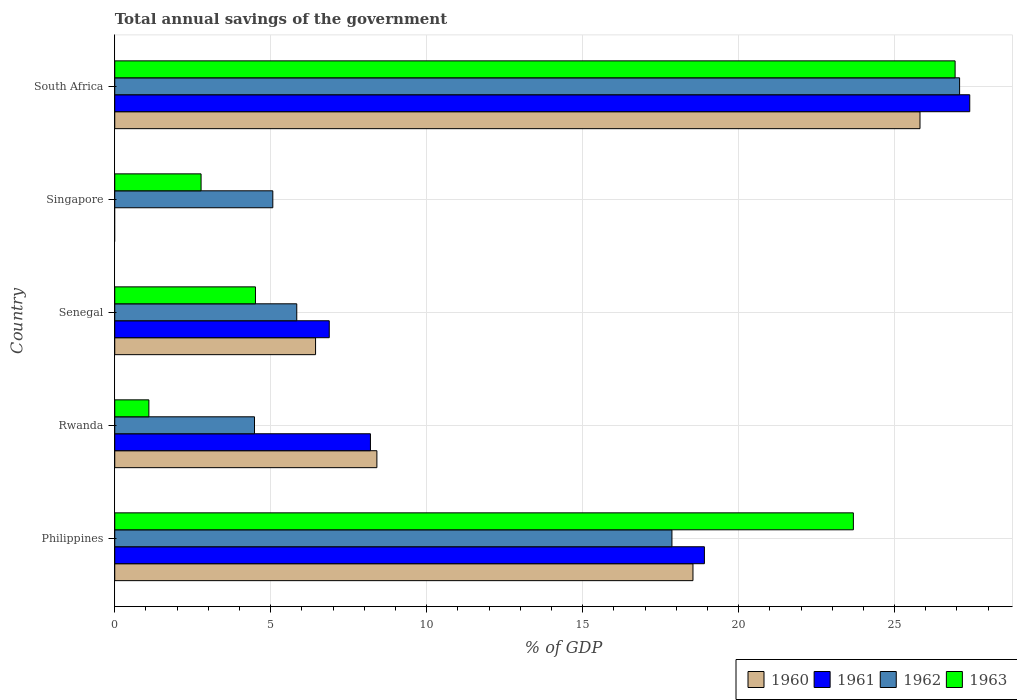Are the number of bars per tick equal to the number of legend labels?
Offer a terse response. No. How many bars are there on the 3rd tick from the top?
Offer a terse response. 4. What is the label of the 2nd group of bars from the top?
Provide a short and direct response. Singapore. What is the total annual savings of the government in 1960 in Senegal?
Ensure brevity in your answer.  6.44. Across all countries, what is the maximum total annual savings of the government in 1960?
Make the answer very short. 25.81. Across all countries, what is the minimum total annual savings of the government in 1960?
Your response must be concise. 0. In which country was the total annual savings of the government in 1962 maximum?
Ensure brevity in your answer.  South Africa. What is the total total annual savings of the government in 1961 in the graph?
Provide a succinct answer. 61.38. What is the difference between the total annual savings of the government in 1962 in Philippines and that in Rwanda?
Make the answer very short. 13.38. What is the difference between the total annual savings of the government in 1962 in Rwanda and the total annual savings of the government in 1961 in Senegal?
Your response must be concise. -2.4. What is the average total annual savings of the government in 1963 per country?
Your answer should be very brief. 11.8. What is the difference between the total annual savings of the government in 1961 and total annual savings of the government in 1962 in Rwanda?
Give a very brief answer. 3.72. What is the ratio of the total annual savings of the government in 1963 in Philippines to that in South Africa?
Offer a very short reply. 0.88. Is the total annual savings of the government in 1962 in Singapore less than that in South Africa?
Your answer should be very brief. Yes. Is the difference between the total annual savings of the government in 1961 in Philippines and Senegal greater than the difference between the total annual savings of the government in 1962 in Philippines and Senegal?
Your answer should be very brief. No. What is the difference between the highest and the second highest total annual savings of the government in 1960?
Your answer should be very brief. 7.28. What is the difference between the highest and the lowest total annual savings of the government in 1960?
Provide a short and direct response. 25.81. In how many countries, is the total annual savings of the government in 1963 greater than the average total annual savings of the government in 1963 taken over all countries?
Give a very brief answer. 2. Is it the case that in every country, the sum of the total annual savings of the government in 1961 and total annual savings of the government in 1963 is greater than the sum of total annual savings of the government in 1960 and total annual savings of the government in 1962?
Give a very brief answer. No. How many countries are there in the graph?
Offer a terse response. 5. Does the graph contain any zero values?
Offer a very short reply. Yes. Where does the legend appear in the graph?
Your answer should be very brief. Bottom right. How many legend labels are there?
Offer a very short reply. 4. How are the legend labels stacked?
Give a very brief answer. Horizontal. What is the title of the graph?
Give a very brief answer. Total annual savings of the government. Does "1986" appear as one of the legend labels in the graph?
Provide a succinct answer. No. What is the label or title of the X-axis?
Your answer should be very brief. % of GDP. What is the % of GDP of 1960 in Philippines?
Give a very brief answer. 18.54. What is the % of GDP of 1961 in Philippines?
Your response must be concise. 18.9. What is the % of GDP of 1962 in Philippines?
Your answer should be very brief. 17.86. What is the % of GDP of 1963 in Philippines?
Keep it short and to the point. 23.68. What is the % of GDP of 1960 in Rwanda?
Give a very brief answer. 8.4. What is the % of GDP in 1961 in Rwanda?
Ensure brevity in your answer.  8.2. What is the % of GDP of 1962 in Rwanda?
Provide a succinct answer. 4.48. What is the % of GDP of 1963 in Rwanda?
Make the answer very short. 1.09. What is the % of GDP in 1960 in Senegal?
Your response must be concise. 6.44. What is the % of GDP of 1961 in Senegal?
Offer a very short reply. 6.88. What is the % of GDP of 1962 in Senegal?
Your answer should be compact. 5.83. What is the % of GDP in 1963 in Senegal?
Your answer should be compact. 4.51. What is the % of GDP of 1961 in Singapore?
Provide a short and direct response. 0. What is the % of GDP in 1962 in Singapore?
Offer a very short reply. 5.07. What is the % of GDP in 1963 in Singapore?
Ensure brevity in your answer.  2.77. What is the % of GDP in 1960 in South Africa?
Make the answer very short. 25.81. What is the % of GDP of 1961 in South Africa?
Offer a very short reply. 27.41. What is the % of GDP in 1962 in South Africa?
Ensure brevity in your answer.  27.08. What is the % of GDP in 1963 in South Africa?
Give a very brief answer. 26.94. Across all countries, what is the maximum % of GDP in 1960?
Offer a very short reply. 25.81. Across all countries, what is the maximum % of GDP in 1961?
Give a very brief answer. 27.41. Across all countries, what is the maximum % of GDP of 1962?
Ensure brevity in your answer.  27.08. Across all countries, what is the maximum % of GDP in 1963?
Offer a terse response. 26.94. Across all countries, what is the minimum % of GDP of 1961?
Offer a terse response. 0. Across all countries, what is the minimum % of GDP in 1962?
Give a very brief answer. 4.48. Across all countries, what is the minimum % of GDP of 1963?
Give a very brief answer. 1.09. What is the total % of GDP in 1960 in the graph?
Your response must be concise. 59.19. What is the total % of GDP of 1961 in the graph?
Provide a succinct answer. 61.38. What is the total % of GDP in 1962 in the graph?
Give a very brief answer. 60.33. What is the total % of GDP in 1963 in the graph?
Provide a short and direct response. 58.99. What is the difference between the % of GDP in 1960 in Philippines and that in Rwanda?
Your response must be concise. 10.13. What is the difference between the % of GDP of 1961 in Philippines and that in Rwanda?
Keep it short and to the point. 10.71. What is the difference between the % of GDP in 1962 in Philippines and that in Rwanda?
Ensure brevity in your answer.  13.38. What is the difference between the % of GDP of 1963 in Philippines and that in Rwanda?
Your response must be concise. 22.58. What is the difference between the % of GDP of 1960 in Philippines and that in Senegal?
Ensure brevity in your answer.  12.1. What is the difference between the % of GDP in 1961 in Philippines and that in Senegal?
Offer a very short reply. 12.03. What is the difference between the % of GDP in 1962 in Philippines and that in Senegal?
Offer a very short reply. 12.03. What is the difference between the % of GDP in 1963 in Philippines and that in Senegal?
Give a very brief answer. 19.17. What is the difference between the % of GDP in 1962 in Philippines and that in Singapore?
Provide a short and direct response. 12.79. What is the difference between the % of GDP in 1963 in Philippines and that in Singapore?
Keep it short and to the point. 20.91. What is the difference between the % of GDP of 1960 in Philippines and that in South Africa?
Ensure brevity in your answer.  -7.28. What is the difference between the % of GDP in 1961 in Philippines and that in South Africa?
Your answer should be compact. -8.51. What is the difference between the % of GDP in 1962 in Philippines and that in South Africa?
Give a very brief answer. -9.22. What is the difference between the % of GDP in 1963 in Philippines and that in South Africa?
Provide a short and direct response. -3.26. What is the difference between the % of GDP of 1960 in Rwanda and that in Senegal?
Provide a short and direct response. 1.97. What is the difference between the % of GDP of 1961 in Rwanda and that in Senegal?
Give a very brief answer. 1.32. What is the difference between the % of GDP of 1962 in Rwanda and that in Senegal?
Offer a very short reply. -1.35. What is the difference between the % of GDP of 1963 in Rwanda and that in Senegal?
Offer a terse response. -3.42. What is the difference between the % of GDP in 1962 in Rwanda and that in Singapore?
Provide a short and direct response. -0.59. What is the difference between the % of GDP of 1963 in Rwanda and that in Singapore?
Ensure brevity in your answer.  -1.67. What is the difference between the % of GDP of 1960 in Rwanda and that in South Africa?
Your answer should be compact. -17.41. What is the difference between the % of GDP of 1961 in Rwanda and that in South Africa?
Your answer should be compact. -19.21. What is the difference between the % of GDP of 1962 in Rwanda and that in South Africa?
Ensure brevity in your answer.  -22.6. What is the difference between the % of GDP in 1963 in Rwanda and that in South Africa?
Keep it short and to the point. -25.85. What is the difference between the % of GDP of 1962 in Senegal and that in Singapore?
Make the answer very short. 0.77. What is the difference between the % of GDP in 1963 in Senegal and that in Singapore?
Your answer should be compact. 1.74. What is the difference between the % of GDP of 1960 in Senegal and that in South Africa?
Make the answer very short. -19.38. What is the difference between the % of GDP of 1961 in Senegal and that in South Africa?
Give a very brief answer. -20.53. What is the difference between the % of GDP in 1962 in Senegal and that in South Africa?
Your answer should be compact. -21.25. What is the difference between the % of GDP of 1963 in Senegal and that in South Africa?
Offer a very short reply. -22.43. What is the difference between the % of GDP in 1962 in Singapore and that in South Africa?
Your response must be concise. -22.02. What is the difference between the % of GDP of 1963 in Singapore and that in South Africa?
Give a very brief answer. -24.17. What is the difference between the % of GDP in 1960 in Philippines and the % of GDP in 1961 in Rwanda?
Ensure brevity in your answer.  10.34. What is the difference between the % of GDP of 1960 in Philippines and the % of GDP of 1962 in Rwanda?
Your answer should be very brief. 14.06. What is the difference between the % of GDP of 1960 in Philippines and the % of GDP of 1963 in Rwanda?
Keep it short and to the point. 17.44. What is the difference between the % of GDP of 1961 in Philippines and the % of GDP of 1962 in Rwanda?
Offer a terse response. 14.42. What is the difference between the % of GDP in 1961 in Philippines and the % of GDP in 1963 in Rwanda?
Offer a terse response. 17.81. What is the difference between the % of GDP in 1962 in Philippines and the % of GDP in 1963 in Rwanda?
Give a very brief answer. 16.77. What is the difference between the % of GDP of 1960 in Philippines and the % of GDP of 1961 in Senegal?
Your response must be concise. 11.66. What is the difference between the % of GDP in 1960 in Philippines and the % of GDP in 1962 in Senegal?
Make the answer very short. 12.7. What is the difference between the % of GDP of 1960 in Philippines and the % of GDP of 1963 in Senegal?
Give a very brief answer. 14.03. What is the difference between the % of GDP in 1961 in Philippines and the % of GDP in 1962 in Senegal?
Ensure brevity in your answer.  13.07. What is the difference between the % of GDP of 1961 in Philippines and the % of GDP of 1963 in Senegal?
Provide a short and direct response. 14.39. What is the difference between the % of GDP in 1962 in Philippines and the % of GDP in 1963 in Senegal?
Give a very brief answer. 13.35. What is the difference between the % of GDP in 1960 in Philippines and the % of GDP in 1962 in Singapore?
Make the answer very short. 13.47. What is the difference between the % of GDP of 1960 in Philippines and the % of GDP of 1963 in Singapore?
Your response must be concise. 15.77. What is the difference between the % of GDP in 1961 in Philippines and the % of GDP in 1962 in Singapore?
Your response must be concise. 13.84. What is the difference between the % of GDP of 1961 in Philippines and the % of GDP of 1963 in Singapore?
Your answer should be compact. 16.14. What is the difference between the % of GDP in 1962 in Philippines and the % of GDP in 1963 in Singapore?
Provide a succinct answer. 15.09. What is the difference between the % of GDP of 1960 in Philippines and the % of GDP of 1961 in South Africa?
Provide a succinct answer. -8.87. What is the difference between the % of GDP of 1960 in Philippines and the % of GDP of 1962 in South Africa?
Ensure brevity in your answer.  -8.55. What is the difference between the % of GDP of 1960 in Philippines and the % of GDP of 1963 in South Africa?
Ensure brevity in your answer.  -8.4. What is the difference between the % of GDP in 1961 in Philippines and the % of GDP in 1962 in South Africa?
Offer a terse response. -8.18. What is the difference between the % of GDP in 1961 in Philippines and the % of GDP in 1963 in South Africa?
Your answer should be compact. -8.04. What is the difference between the % of GDP of 1962 in Philippines and the % of GDP of 1963 in South Africa?
Offer a terse response. -9.08. What is the difference between the % of GDP in 1960 in Rwanda and the % of GDP in 1961 in Senegal?
Give a very brief answer. 1.53. What is the difference between the % of GDP of 1960 in Rwanda and the % of GDP of 1962 in Senegal?
Offer a very short reply. 2.57. What is the difference between the % of GDP in 1960 in Rwanda and the % of GDP in 1963 in Senegal?
Offer a very short reply. 3.89. What is the difference between the % of GDP in 1961 in Rwanda and the % of GDP in 1962 in Senegal?
Offer a very short reply. 2.36. What is the difference between the % of GDP of 1961 in Rwanda and the % of GDP of 1963 in Senegal?
Provide a succinct answer. 3.69. What is the difference between the % of GDP in 1962 in Rwanda and the % of GDP in 1963 in Senegal?
Ensure brevity in your answer.  -0.03. What is the difference between the % of GDP in 1960 in Rwanda and the % of GDP in 1962 in Singapore?
Your response must be concise. 3.34. What is the difference between the % of GDP of 1960 in Rwanda and the % of GDP of 1963 in Singapore?
Offer a terse response. 5.64. What is the difference between the % of GDP in 1961 in Rwanda and the % of GDP in 1962 in Singapore?
Your answer should be compact. 3.13. What is the difference between the % of GDP of 1961 in Rwanda and the % of GDP of 1963 in Singapore?
Provide a short and direct response. 5.43. What is the difference between the % of GDP of 1962 in Rwanda and the % of GDP of 1963 in Singapore?
Provide a succinct answer. 1.71. What is the difference between the % of GDP of 1960 in Rwanda and the % of GDP of 1961 in South Africa?
Your answer should be very brief. -19.01. What is the difference between the % of GDP of 1960 in Rwanda and the % of GDP of 1962 in South Africa?
Your response must be concise. -18.68. What is the difference between the % of GDP of 1960 in Rwanda and the % of GDP of 1963 in South Africa?
Your response must be concise. -18.54. What is the difference between the % of GDP of 1961 in Rwanda and the % of GDP of 1962 in South Africa?
Give a very brief answer. -18.89. What is the difference between the % of GDP of 1961 in Rwanda and the % of GDP of 1963 in South Africa?
Offer a terse response. -18.74. What is the difference between the % of GDP in 1962 in Rwanda and the % of GDP in 1963 in South Africa?
Provide a succinct answer. -22.46. What is the difference between the % of GDP of 1960 in Senegal and the % of GDP of 1962 in Singapore?
Your answer should be compact. 1.37. What is the difference between the % of GDP in 1960 in Senegal and the % of GDP in 1963 in Singapore?
Give a very brief answer. 3.67. What is the difference between the % of GDP in 1961 in Senegal and the % of GDP in 1962 in Singapore?
Provide a short and direct response. 1.81. What is the difference between the % of GDP in 1961 in Senegal and the % of GDP in 1963 in Singapore?
Offer a very short reply. 4.11. What is the difference between the % of GDP in 1962 in Senegal and the % of GDP in 1963 in Singapore?
Ensure brevity in your answer.  3.07. What is the difference between the % of GDP in 1960 in Senegal and the % of GDP in 1961 in South Africa?
Your answer should be very brief. -20.97. What is the difference between the % of GDP in 1960 in Senegal and the % of GDP in 1962 in South Africa?
Provide a succinct answer. -20.65. What is the difference between the % of GDP in 1960 in Senegal and the % of GDP in 1963 in South Africa?
Ensure brevity in your answer.  -20.5. What is the difference between the % of GDP in 1961 in Senegal and the % of GDP in 1962 in South Africa?
Keep it short and to the point. -20.21. What is the difference between the % of GDP in 1961 in Senegal and the % of GDP in 1963 in South Africa?
Your answer should be very brief. -20.06. What is the difference between the % of GDP of 1962 in Senegal and the % of GDP of 1963 in South Africa?
Offer a terse response. -21.11. What is the difference between the % of GDP of 1962 in Singapore and the % of GDP of 1963 in South Africa?
Offer a terse response. -21.87. What is the average % of GDP in 1960 per country?
Provide a short and direct response. 11.84. What is the average % of GDP in 1961 per country?
Provide a succinct answer. 12.28. What is the average % of GDP of 1962 per country?
Keep it short and to the point. 12.07. What is the average % of GDP of 1963 per country?
Keep it short and to the point. 11.8. What is the difference between the % of GDP in 1960 and % of GDP in 1961 in Philippines?
Provide a succinct answer. -0.37. What is the difference between the % of GDP of 1960 and % of GDP of 1962 in Philippines?
Your answer should be compact. 0.67. What is the difference between the % of GDP of 1960 and % of GDP of 1963 in Philippines?
Offer a terse response. -5.14. What is the difference between the % of GDP of 1961 and % of GDP of 1962 in Philippines?
Ensure brevity in your answer.  1.04. What is the difference between the % of GDP of 1961 and % of GDP of 1963 in Philippines?
Keep it short and to the point. -4.78. What is the difference between the % of GDP of 1962 and % of GDP of 1963 in Philippines?
Your answer should be very brief. -5.82. What is the difference between the % of GDP in 1960 and % of GDP in 1961 in Rwanda?
Ensure brevity in your answer.  0.21. What is the difference between the % of GDP in 1960 and % of GDP in 1962 in Rwanda?
Provide a succinct answer. 3.92. What is the difference between the % of GDP of 1960 and % of GDP of 1963 in Rwanda?
Make the answer very short. 7.31. What is the difference between the % of GDP of 1961 and % of GDP of 1962 in Rwanda?
Offer a terse response. 3.72. What is the difference between the % of GDP of 1961 and % of GDP of 1963 in Rwanda?
Your response must be concise. 7.1. What is the difference between the % of GDP of 1962 and % of GDP of 1963 in Rwanda?
Offer a terse response. 3.39. What is the difference between the % of GDP in 1960 and % of GDP in 1961 in Senegal?
Provide a succinct answer. -0.44. What is the difference between the % of GDP of 1960 and % of GDP of 1962 in Senegal?
Your answer should be compact. 0.6. What is the difference between the % of GDP of 1960 and % of GDP of 1963 in Senegal?
Offer a very short reply. 1.93. What is the difference between the % of GDP in 1961 and % of GDP in 1962 in Senegal?
Provide a short and direct response. 1.04. What is the difference between the % of GDP in 1961 and % of GDP in 1963 in Senegal?
Offer a very short reply. 2.37. What is the difference between the % of GDP in 1962 and % of GDP in 1963 in Senegal?
Make the answer very short. 1.32. What is the difference between the % of GDP in 1962 and % of GDP in 1963 in Singapore?
Keep it short and to the point. 2.3. What is the difference between the % of GDP of 1960 and % of GDP of 1961 in South Africa?
Make the answer very short. -1.59. What is the difference between the % of GDP of 1960 and % of GDP of 1962 in South Africa?
Offer a terse response. -1.27. What is the difference between the % of GDP in 1960 and % of GDP in 1963 in South Africa?
Keep it short and to the point. -1.13. What is the difference between the % of GDP in 1961 and % of GDP in 1962 in South Africa?
Make the answer very short. 0.33. What is the difference between the % of GDP of 1961 and % of GDP of 1963 in South Africa?
Give a very brief answer. 0.47. What is the difference between the % of GDP of 1962 and % of GDP of 1963 in South Africa?
Keep it short and to the point. 0.14. What is the ratio of the % of GDP of 1960 in Philippines to that in Rwanda?
Offer a very short reply. 2.21. What is the ratio of the % of GDP of 1961 in Philippines to that in Rwanda?
Your response must be concise. 2.31. What is the ratio of the % of GDP of 1962 in Philippines to that in Rwanda?
Your response must be concise. 3.99. What is the ratio of the % of GDP in 1963 in Philippines to that in Rwanda?
Provide a short and direct response. 21.65. What is the ratio of the % of GDP of 1960 in Philippines to that in Senegal?
Keep it short and to the point. 2.88. What is the ratio of the % of GDP in 1961 in Philippines to that in Senegal?
Ensure brevity in your answer.  2.75. What is the ratio of the % of GDP in 1962 in Philippines to that in Senegal?
Make the answer very short. 3.06. What is the ratio of the % of GDP in 1963 in Philippines to that in Senegal?
Provide a succinct answer. 5.25. What is the ratio of the % of GDP of 1962 in Philippines to that in Singapore?
Offer a terse response. 3.53. What is the ratio of the % of GDP of 1963 in Philippines to that in Singapore?
Provide a succinct answer. 8.56. What is the ratio of the % of GDP of 1960 in Philippines to that in South Africa?
Make the answer very short. 0.72. What is the ratio of the % of GDP of 1961 in Philippines to that in South Africa?
Your response must be concise. 0.69. What is the ratio of the % of GDP in 1962 in Philippines to that in South Africa?
Give a very brief answer. 0.66. What is the ratio of the % of GDP in 1963 in Philippines to that in South Africa?
Your answer should be compact. 0.88. What is the ratio of the % of GDP of 1960 in Rwanda to that in Senegal?
Your answer should be very brief. 1.31. What is the ratio of the % of GDP in 1961 in Rwanda to that in Senegal?
Your response must be concise. 1.19. What is the ratio of the % of GDP in 1962 in Rwanda to that in Senegal?
Provide a short and direct response. 0.77. What is the ratio of the % of GDP in 1963 in Rwanda to that in Senegal?
Make the answer very short. 0.24. What is the ratio of the % of GDP of 1962 in Rwanda to that in Singapore?
Your answer should be compact. 0.88. What is the ratio of the % of GDP of 1963 in Rwanda to that in Singapore?
Your response must be concise. 0.4. What is the ratio of the % of GDP in 1960 in Rwanda to that in South Africa?
Your answer should be compact. 0.33. What is the ratio of the % of GDP in 1961 in Rwanda to that in South Africa?
Give a very brief answer. 0.3. What is the ratio of the % of GDP in 1962 in Rwanda to that in South Africa?
Offer a very short reply. 0.17. What is the ratio of the % of GDP of 1963 in Rwanda to that in South Africa?
Provide a short and direct response. 0.04. What is the ratio of the % of GDP in 1962 in Senegal to that in Singapore?
Give a very brief answer. 1.15. What is the ratio of the % of GDP of 1963 in Senegal to that in Singapore?
Your answer should be compact. 1.63. What is the ratio of the % of GDP in 1960 in Senegal to that in South Africa?
Keep it short and to the point. 0.25. What is the ratio of the % of GDP of 1961 in Senegal to that in South Africa?
Provide a succinct answer. 0.25. What is the ratio of the % of GDP in 1962 in Senegal to that in South Africa?
Your response must be concise. 0.22. What is the ratio of the % of GDP of 1963 in Senegal to that in South Africa?
Your answer should be very brief. 0.17. What is the ratio of the % of GDP of 1962 in Singapore to that in South Africa?
Give a very brief answer. 0.19. What is the ratio of the % of GDP in 1963 in Singapore to that in South Africa?
Offer a very short reply. 0.1. What is the difference between the highest and the second highest % of GDP in 1960?
Ensure brevity in your answer.  7.28. What is the difference between the highest and the second highest % of GDP of 1961?
Offer a very short reply. 8.51. What is the difference between the highest and the second highest % of GDP of 1962?
Give a very brief answer. 9.22. What is the difference between the highest and the second highest % of GDP in 1963?
Your response must be concise. 3.26. What is the difference between the highest and the lowest % of GDP of 1960?
Offer a very short reply. 25.81. What is the difference between the highest and the lowest % of GDP of 1961?
Keep it short and to the point. 27.41. What is the difference between the highest and the lowest % of GDP in 1962?
Offer a terse response. 22.6. What is the difference between the highest and the lowest % of GDP of 1963?
Give a very brief answer. 25.85. 